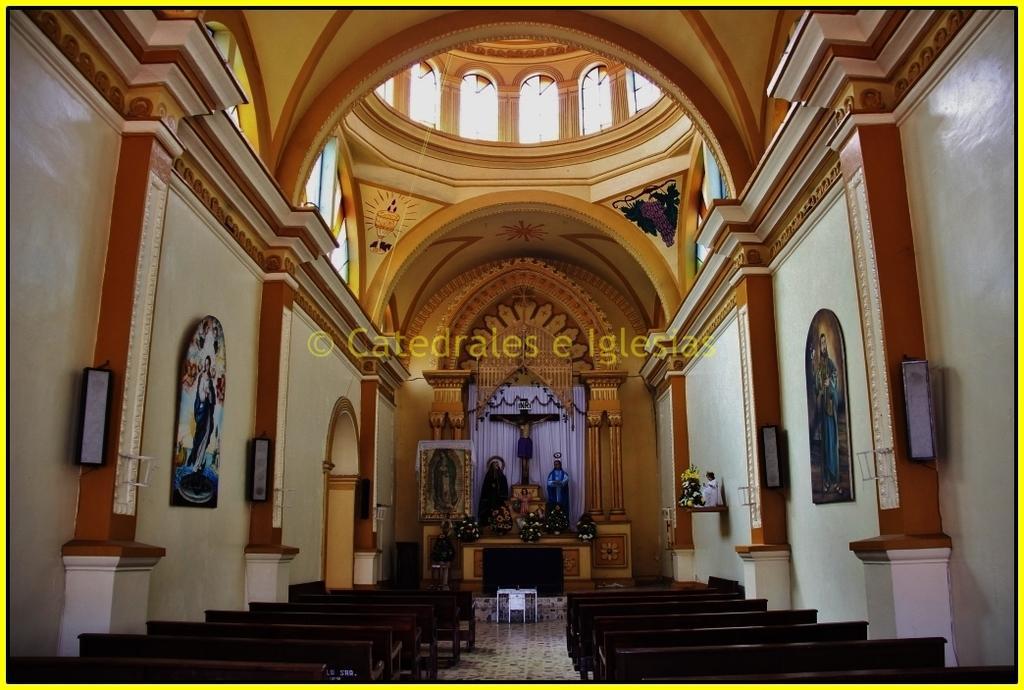How would you summarize this image in a sentence or two? In this picture we can see benches on the floor, pillars, speakers, frames on the wall, curtains, statues, flowers, ceiling and some text. 